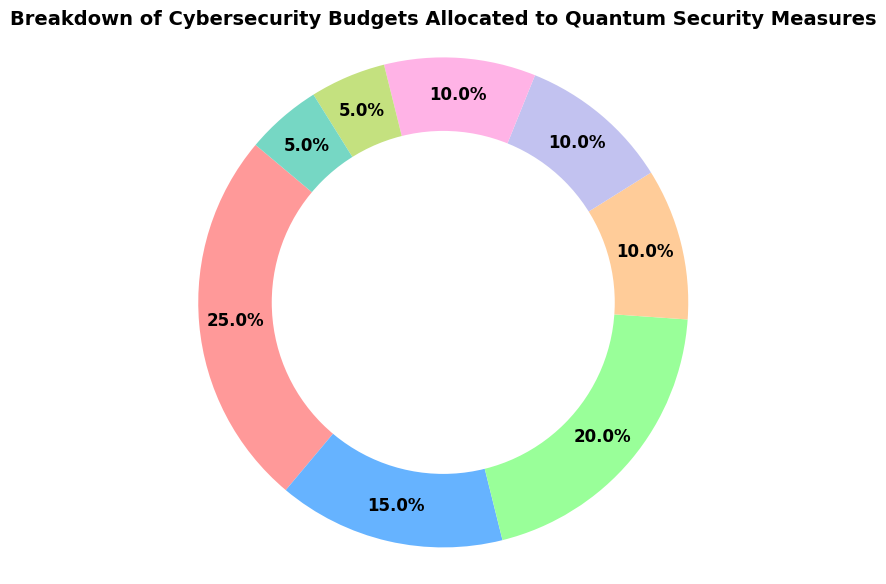what sector allocates the highest percentage to quantum security measures? By examining the figure, locate the largest slice in the pie chart. This slice represents the sector with the highest percentage allocation to quantum security measures.
Answer: Finance Which sectors allocate the same percentage of their budgets to quantum security measures? Identify the sectors that have equally sized slices in the pie chart.
Answer: Manufacturing, Energy, Telecommunications What is the combined percentage of the total budget allocated to quantum security measures by the Energy and Manufacturing sectors? Sum the percentages allocated by the Energy and Manufacturing sectors by adding their individual percentages (10% + 10%).
Answer: 20% How does the percentage allocation for Retail compare to Healthcare? Compare the sizes of the pie chart slices for Retail and Healthcare. Retail allocates 5%, while Healthcare allocates 15%. Retail's allocation is one-third of Healthcare's.
Answer: Retail allocates less than Healthcare What percentage of the total budget is allocated by the Finance and Government sectors combined, compared to the Telecommunications and Retail sectors combined? Sum the percentages for Finance and Government (25% + 20%) and for Telecommunications and Retail (10% + 5%) and then compare (45% vs 15%).
Answer: Finance and Government more than Telecommunication and Retail How much larger is the Healthcare slice compared to Energy in terms of percentage points? Subtract the percentage allocation of Energy from Healthcare (15% - 10%).
Answer: 5% Which sector has the smallest allocation to quantum security measures, and what percentage does it represent? Find the smallest slice in the pie chart and identify its corresponding sector and percentage.
Answer: Retail and Education, 5% Is the allocation for Education greater than or equal to that of Telecommunications? Compare the pie chart slices for Education and Telecommunications. Education allocates 5%, while Telecommunications allocates 10%. Education's allocation is not greater than Telecommunications.
Answer: No What is the average budget allocation across all the sectors? Sum the percentages allocated to each sector (25% + 15% + 20% + 10% + 10% + 10% + 5% + 5%) and divide by the number of sectors (8).
Answer: 12.5% If Education and Retail doubled their allocation, what would be their new percentages? Multiply the current percentages of Education and Retail by 2 (5% * 2 = 10% for both).
Answer: 10% 